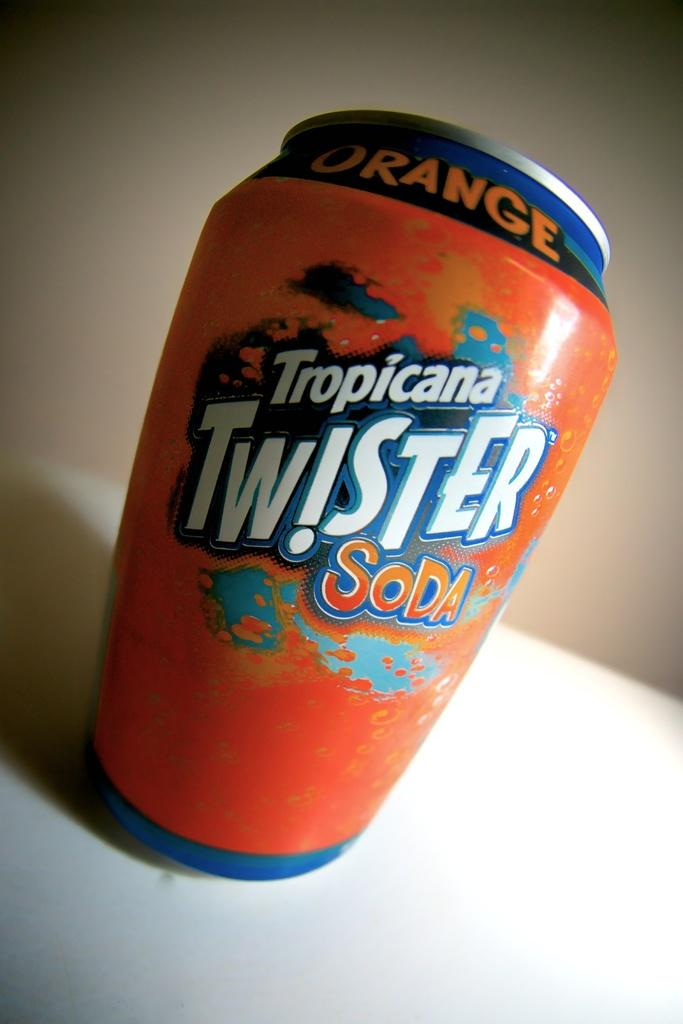<image>
Relay a brief, clear account of the picture shown. An orange and blue can of orange Tropicana Twister soda. 